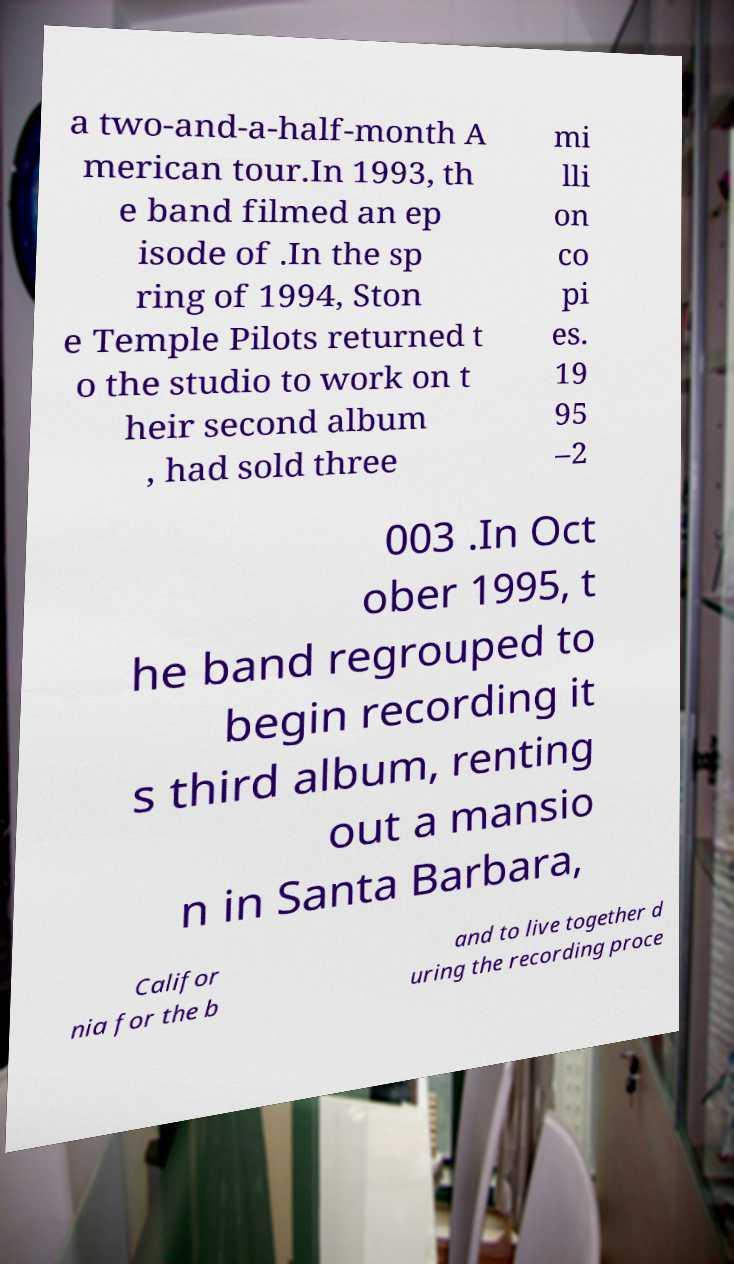There's text embedded in this image that I need extracted. Can you transcribe it verbatim? a two-and-a-half-month A merican tour.In 1993, th e band filmed an ep isode of .In the sp ring of 1994, Ston e Temple Pilots returned t o the studio to work on t heir second album , had sold three mi lli on co pi es. 19 95 –2 003 .In Oct ober 1995, t he band regrouped to begin recording it s third album, renting out a mansio n in Santa Barbara, Califor nia for the b and to live together d uring the recording proce 